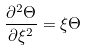Convert formula to latex. <formula><loc_0><loc_0><loc_500><loc_500>\frac { \partial ^ { 2 } \Theta } { \partial \xi ^ { 2 } } = \xi \Theta</formula> 